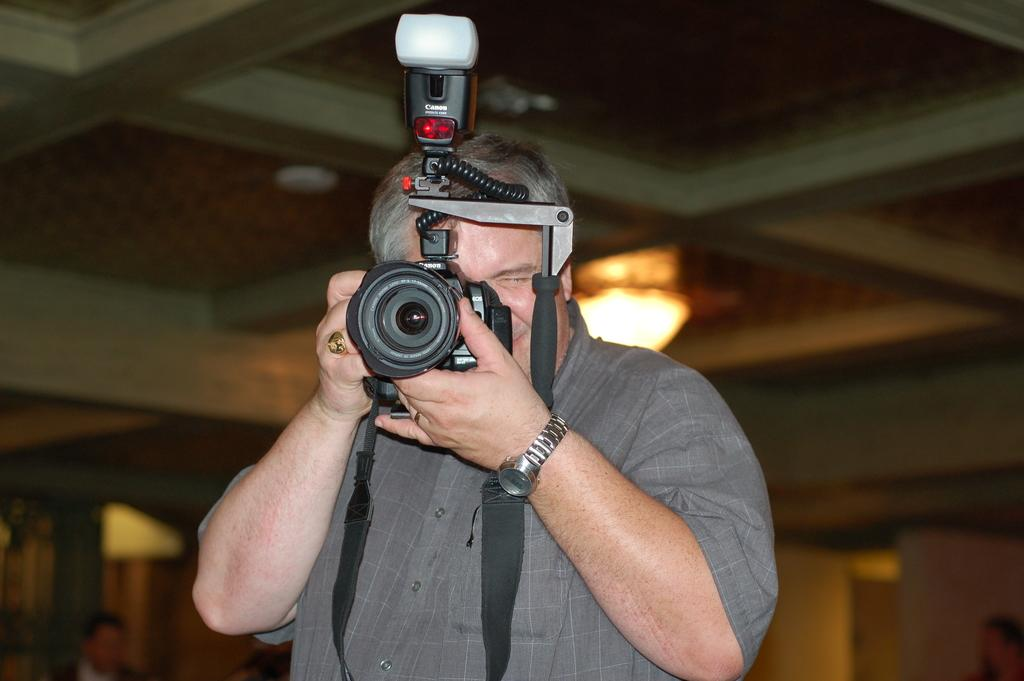What is the man in the image doing? The man in the image is holding a camera. What is the man's facial expression in the image? The man is smiling in the image. How would you describe the background of the image? The background of the image is blurry. What can be seen in the image besides the man? There is a light visible in the image, and there are people at the bottom of the image. What type of owl can be seen perched on the man's shoulder in the image? There is no owl present in the image; the man is holding a camera. What type of polish is the man applying to his nails in the image? The man is not applying any polish to his nails in the image; he is holding a camera and smiling. 